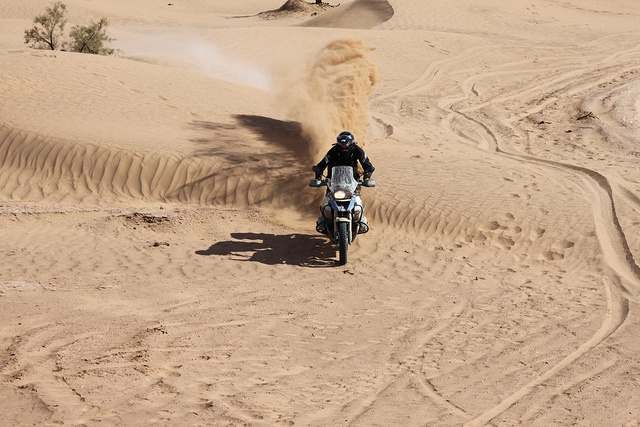Describe the objects in this image and their specific colors. I can see motorcycle in tan, black, gray, darkgray, and lightgray tones and people in tan, black, gray, and maroon tones in this image. 